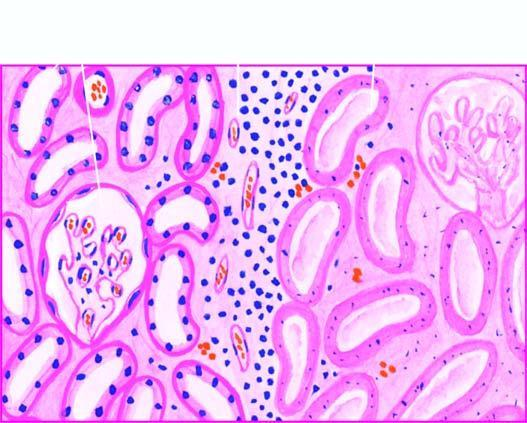does the affected area on right show non-specific chronic inflammation and proliferating vessels?
Answer the question using a single word or phrase. No 